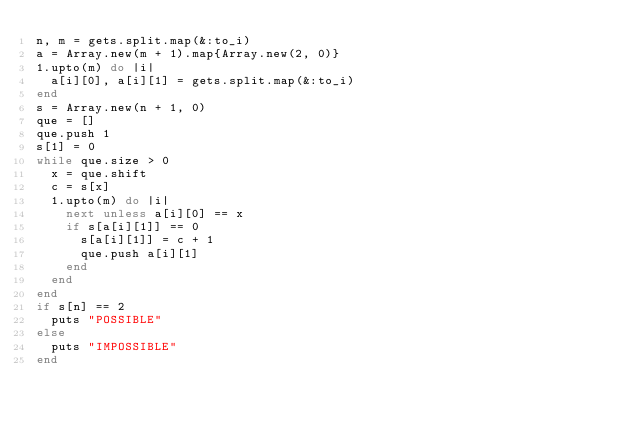<code> <loc_0><loc_0><loc_500><loc_500><_Ruby_>n, m = gets.split.map(&:to_i)
a = Array.new(m + 1).map{Array.new(2, 0)}
1.upto(m) do |i|
  a[i][0], a[i][1] = gets.split.map(&:to_i)
end
s = Array.new(n + 1, 0)
que = []
que.push 1
s[1] = 0
while que.size > 0
  x = que.shift
  c = s[x]
  1.upto(m) do |i|
    next unless a[i][0] == x
    if s[a[i][1]] == 0
      s[a[i][1]] = c + 1
      que.push a[i][1]
    end
  end
end
if s[n] == 2
  puts "POSSIBLE"
else
  puts "IMPOSSIBLE"
end</code> 